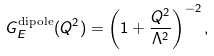<formula> <loc_0><loc_0><loc_500><loc_500>G _ { E } ^ { \text {dipole} } ( Q ^ { 2 } ) = \left ( 1 + \frac { Q ^ { 2 } } { \Lambda ^ { 2 } } \right ) ^ { - 2 } ,</formula> 